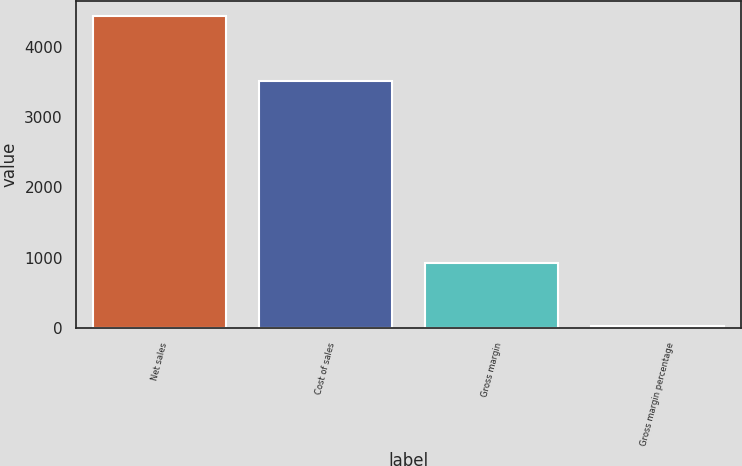Convert chart. <chart><loc_0><loc_0><loc_500><loc_500><bar_chart><fcel>Net sales<fcel>Cost of sales<fcel>Gross margin<fcel>Gross margin percentage<nl><fcel>4429<fcel>3512<fcel>917<fcel>20.7<nl></chart> 